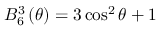<formula> <loc_0><loc_0><loc_500><loc_500>B _ { 6 } ^ { 3 } \left ( \theta \right ) = 3 \cos ^ { 2 } \theta + 1</formula> 